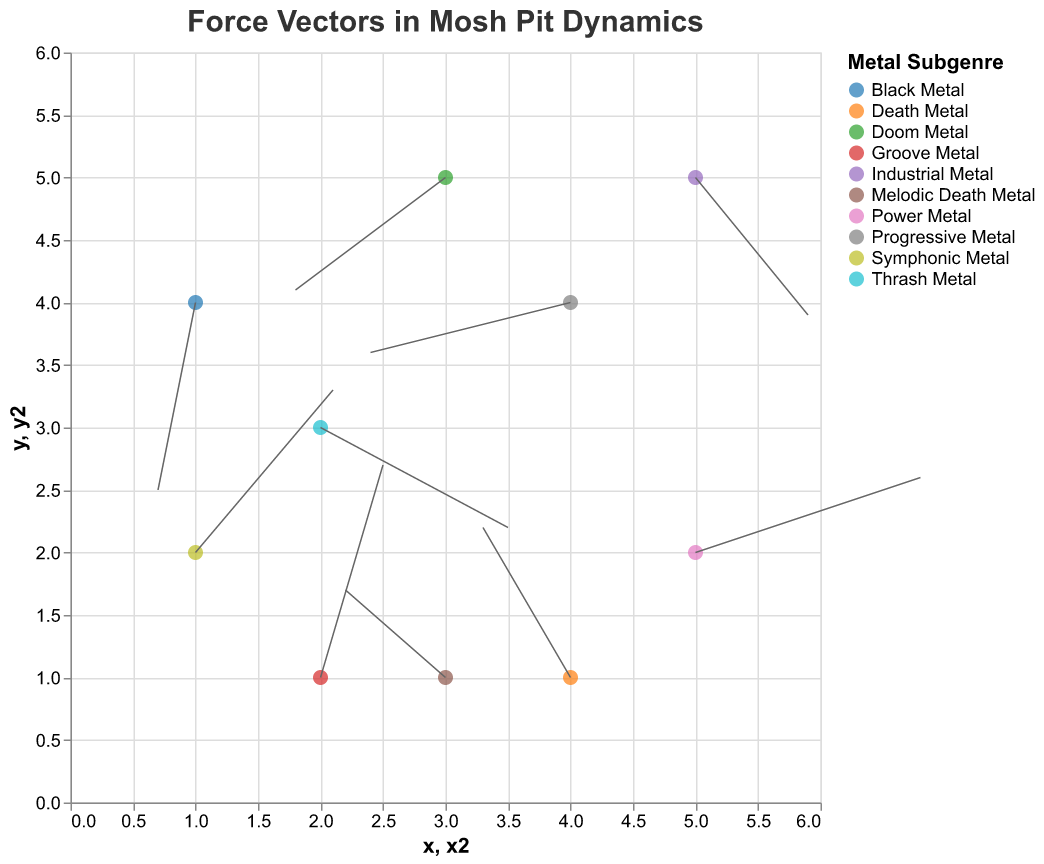What's the title of the plot? The title of the plot is located at the top and usually in a larger font size than other text elements.
Answer: Force Vectors in Mosh Pit Dynamics How many data points are represented in the plot? The plot has one mark for each data point. Count all the distinct marks to determine the number of data points.
Answer: 10 Which metal subgenre shows the largest magnitude of vectors? The magnitude of vectors is calculated using the formula √(u² + v²). Compare the magnitudes for all subgenres. Thrash Metal has a vector with magnitude √(1.5² + (-0.8)²) ≈ 1.7, and Power Metal has a vector magnitude of √(1.8² + 0.6²) ≈ 1.9. Continue comparing to find the largest.
Answer: Power Metal What is the direction of the vector for Death Metal? The direction of a vector can be interpreted as an angle from the positive x-axis. For Death Metal (u = -0.7, v = 1.2), the direction is primarily upwards and leftwards. Specifically, the arctangent of the ratio v/u provides the angle. In this case, arctan(1.2/-0.7) indicates an angle in the second quadrant.
Answer: Up and to the left Which subgenre has a vector moving downwards and to the left, and what are its coordinates? A vector moving downwards and to the left will have both u and v components negative. Check each subgenre to see which has < 0 directions for both u and v. Black Metal has (u = -0.3, v = -1.5) fitting this criteria.
Answer: Black Metal, (1, 4) Which subgenre has the vector with the largest horizontal component? Evaluate the absolute value of the u component for each subgenre. Power Metal has u = 1.8, which appears to be the largest value. Comparison confirms no other subgenre exceeds this horizontal component.
Answer: Power Metal Which vector starts at coordinates (2, 1), and what is its end point? Locate the initial coordinates (2, 1) and then compute the endpoint using the formula (x + u, y + v). For Groove Metal with initial coordinates (2, 1) and vector (u = 0.5, v = 1.7), the end point is (2 + 0.5, 1 + 1.7) = (2.5, 2.7).
Answer: Groove Metal, (2.5, 2.7) Between Doom Metal and Symphonic Metal, which subgenre's vector moves further and what is the distance of the vector? Calculate the vector magnitude for Doom Metal (u = -1.2, v = -0.9) and Symphonic Metal (u = 1.1, v = 1.3) using √(u² + v²). For Doom Metal, the magnitude is √((-1.2)² + (-0.9)²) ≈ 1.5. For Symphonic Metal, the magnitude is √((1.1)² + (1.3)²) ≈ 1.7. Therefore, Symphonic Metal's vector moves further.
Answer: Symphonic Metal, 1.7 Which subgenre has a vector starting at coordinates (4, 4), and what are its components? Look for the starting coordinate (4, 4) and identify the subgenre. Inspect the corresponding vector components (u = -1.6, v = -0.4).
Answer: Progressive Metal, (-1.6, -0.4) Among all vectors moving upward, which has the highest vertical component? Examine the v components (those > 0) of vectors; find the maximum value. Groove Metal has v = 1.7 which is the highest among vertical components where v > 0.
Answer: Groove Metal 